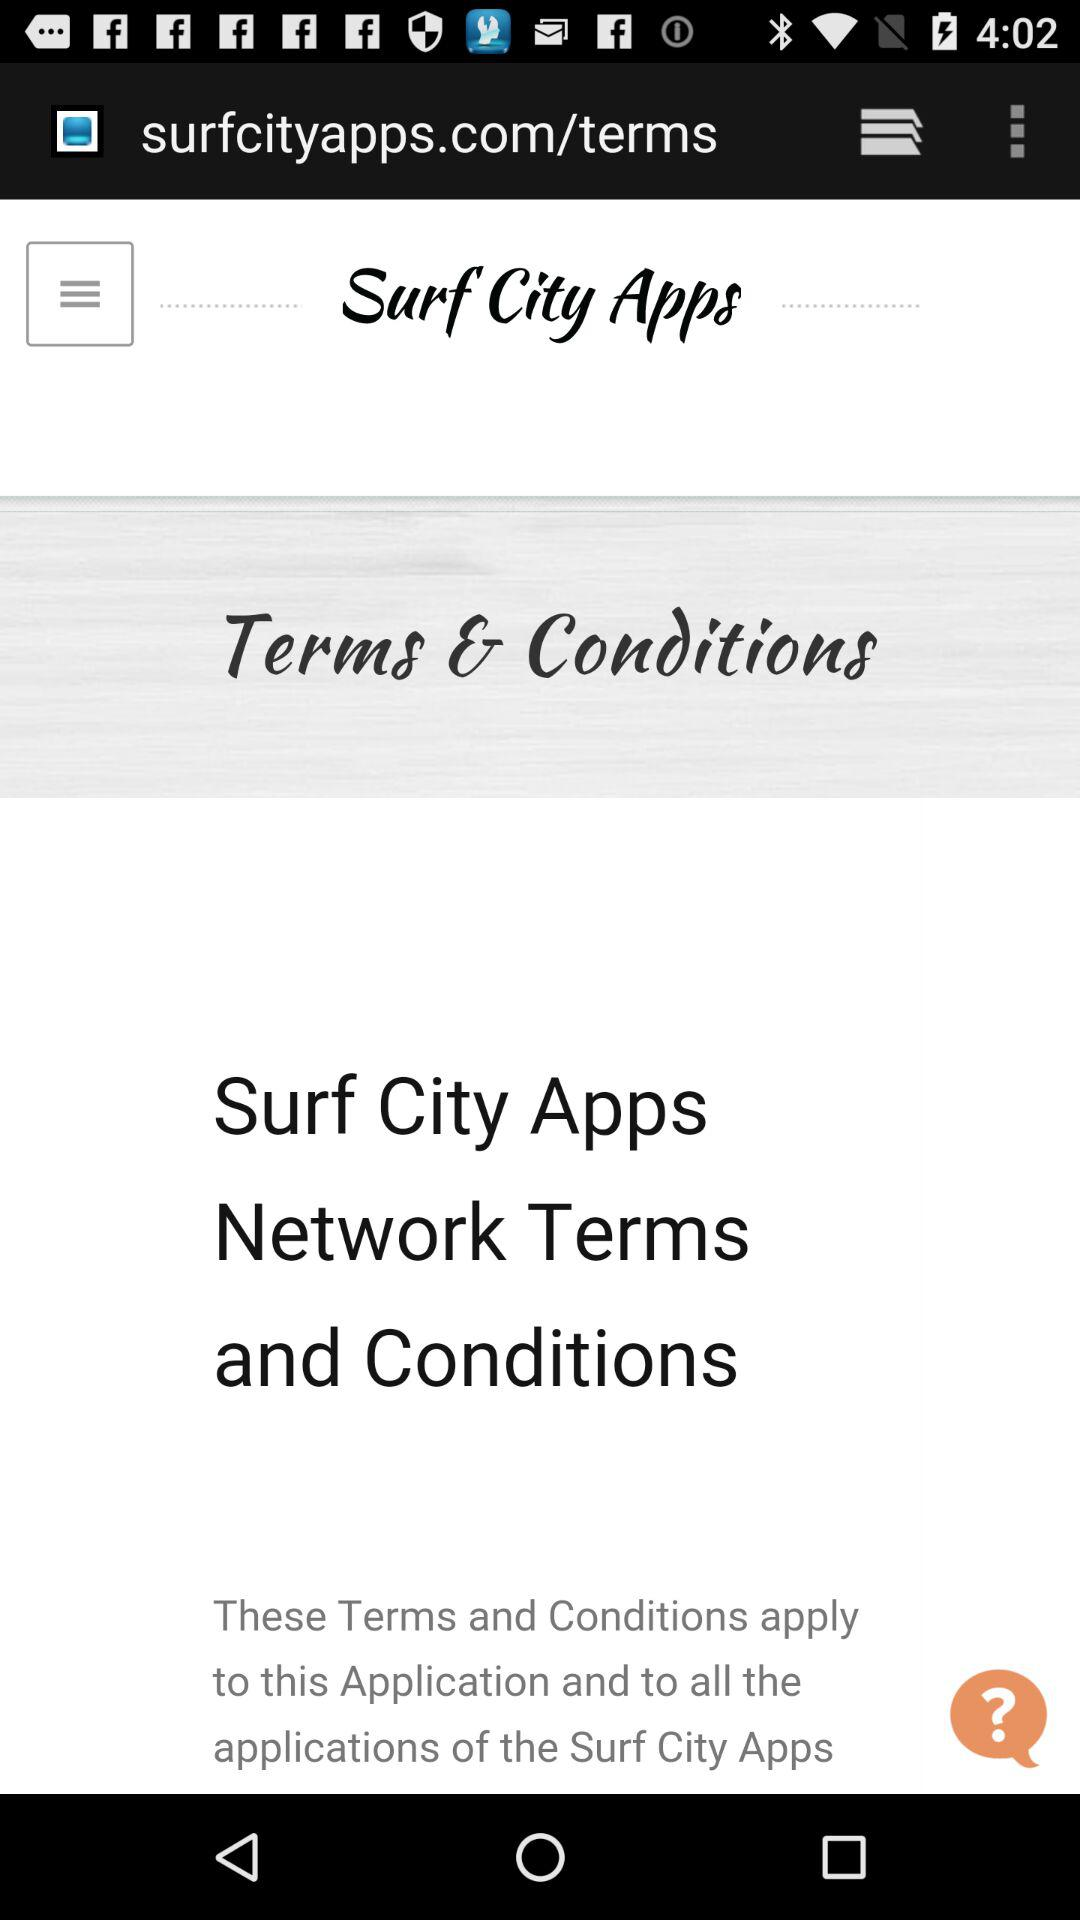What is the application name?
When the provided information is insufficient, respond with <no answer>. <no answer> 